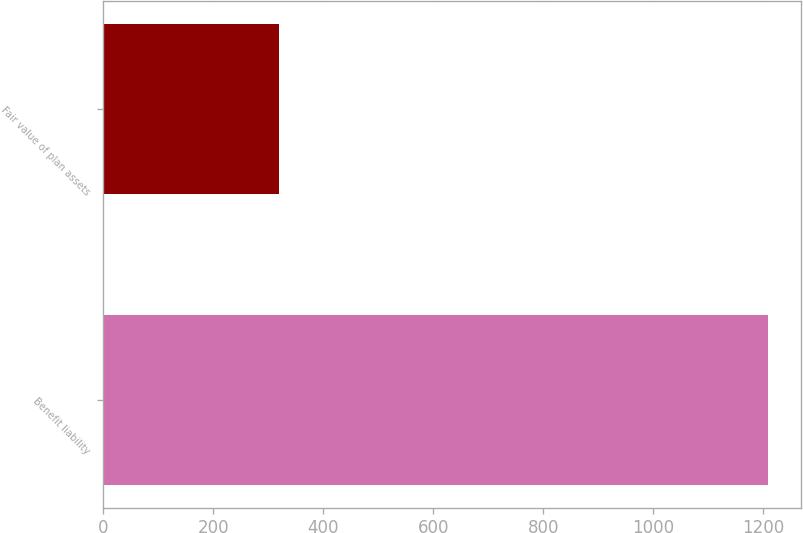Convert chart. <chart><loc_0><loc_0><loc_500><loc_500><bar_chart><fcel>Benefit liability<fcel>Fair value of plan assets<nl><fcel>1208<fcel>320<nl></chart> 